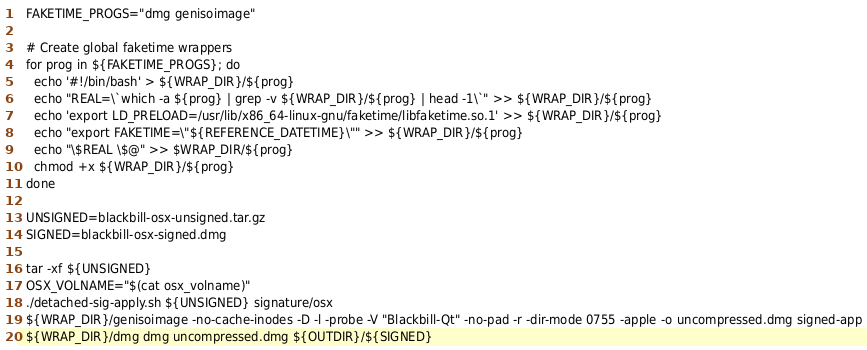Convert code to text. <code><loc_0><loc_0><loc_500><loc_500><_YAML_>  FAKETIME_PROGS="dmg genisoimage"

  # Create global faketime wrappers
  for prog in ${FAKETIME_PROGS}; do
    echo '#!/bin/bash' > ${WRAP_DIR}/${prog}
    echo "REAL=\`which -a ${prog} | grep -v ${WRAP_DIR}/${prog} | head -1\`" >> ${WRAP_DIR}/${prog}
    echo 'export LD_PRELOAD=/usr/lib/x86_64-linux-gnu/faketime/libfaketime.so.1' >> ${WRAP_DIR}/${prog}
    echo "export FAKETIME=\"${REFERENCE_DATETIME}\"" >> ${WRAP_DIR}/${prog}
    echo "\$REAL \$@" >> $WRAP_DIR/${prog}
    chmod +x ${WRAP_DIR}/${prog}
  done

  UNSIGNED=blackbill-osx-unsigned.tar.gz
  SIGNED=blackbill-osx-signed.dmg

  tar -xf ${UNSIGNED}
  OSX_VOLNAME="$(cat osx_volname)"
  ./detached-sig-apply.sh ${UNSIGNED} signature/osx
  ${WRAP_DIR}/genisoimage -no-cache-inodes -D -l -probe -V "Blackbill-Qt" -no-pad -r -dir-mode 0755 -apple -o uncompressed.dmg signed-app
  ${WRAP_DIR}/dmg dmg uncompressed.dmg ${OUTDIR}/${SIGNED}
</code> 